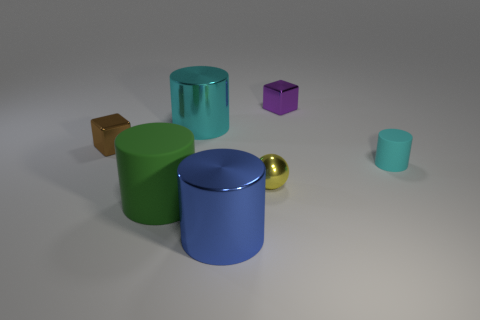Subtract all brown balls. Subtract all yellow blocks. How many balls are left? 1 Subtract all blue cubes. How many brown balls are left? 0 Add 2 small browns. How many small things exist? 0 Subtract all small cyan cylinders. Subtract all metallic blocks. How many objects are left? 4 Add 4 brown objects. How many brown objects are left? 5 Add 5 brown metallic balls. How many brown metallic balls exist? 5 Add 2 blue cylinders. How many objects exist? 9 Subtract all blue cylinders. How many cylinders are left? 3 Subtract all big green rubber cylinders. How many cylinders are left? 3 Subtract 1 brown cubes. How many objects are left? 6 